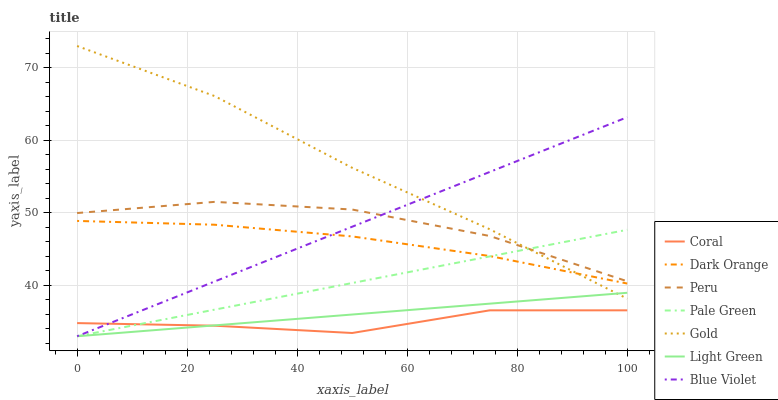Does Coral have the minimum area under the curve?
Answer yes or no. Yes. Does Gold have the maximum area under the curve?
Answer yes or no. Yes. Does Peru have the minimum area under the curve?
Answer yes or no. No. Does Peru have the maximum area under the curve?
Answer yes or no. No. Is Pale Green the smoothest?
Answer yes or no. Yes. Is Coral the roughest?
Answer yes or no. Yes. Is Peru the smoothest?
Answer yes or no. No. Is Peru the roughest?
Answer yes or no. No. Does Pale Green have the lowest value?
Answer yes or no. Yes. Does Gold have the lowest value?
Answer yes or no. No. Does Gold have the highest value?
Answer yes or no. Yes. Does Peru have the highest value?
Answer yes or no. No. Is Coral less than Dark Orange?
Answer yes or no. Yes. Is Gold greater than Coral?
Answer yes or no. Yes. Does Pale Green intersect Blue Violet?
Answer yes or no. Yes. Is Pale Green less than Blue Violet?
Answer yes or no. No. Is Pale Green greater than Blue Violet?
Answer yes or no. No. Does Coral intersect Dark Orange?
Answer yes or no. No. 